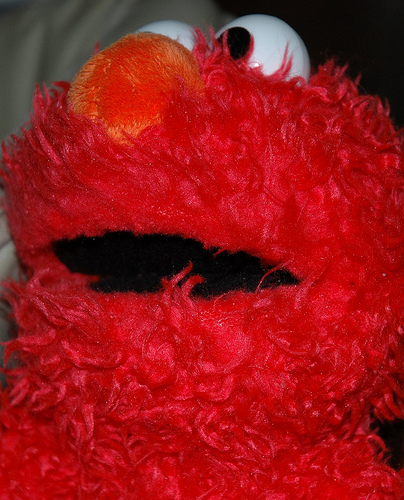<image>
Is the pupil on the eyeball? No. The pupil is not positioned on the eyeball. They may be near each other, but the pupil is not supported by or resting on top of the eyeball. 